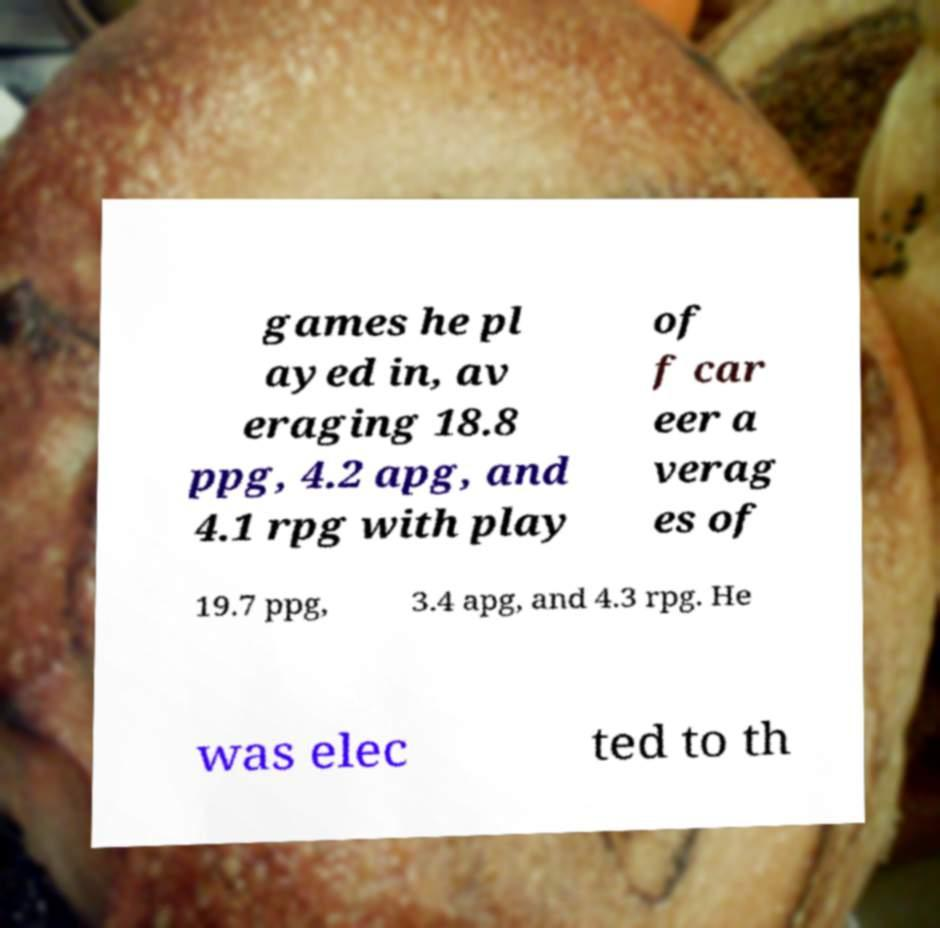There's text embedded in this image that I need extracted. Can you transcribe it verbatim? games he pl ayed in, av eraging 18.8 ppg, 4.2 apg, and 4.1 rpg with play of f car eer a verag es of 19.7 ppg, 3.4 apg, and 4.3 rpg. He was elec ted to th 